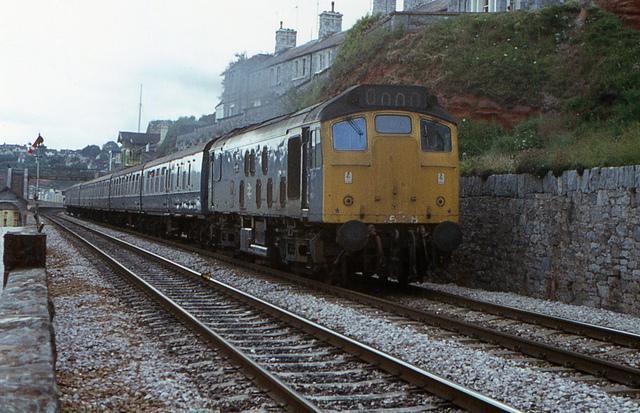How many people are wearing hats?
Give a very brief answer. 0. 